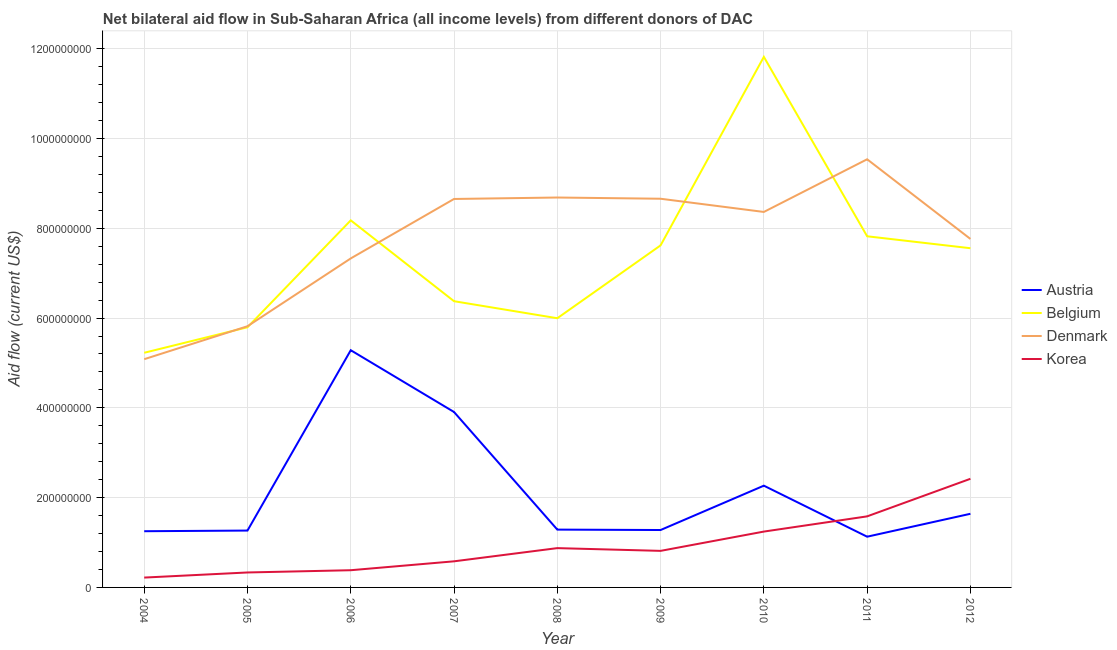Is the number of lines equal to the number of legend labels?
Make the answer very short. Yes. What is the amount of aid given by belgium in 2009?
Your answer should be very brief. 7.62e+08. Across all years, what is the maximum amount of aid given by austria?
Provide a short and direct response. 5.28e+08. Across all years, what is the minimum amount of aid given by belgium?
Provide a short and direct response. 5.23e+08. In which year was the amount of aid given by austria maximum?
Ensure brevity in your answer.  2006. In which year was the amount of aid given by austria minimum?
Your answer should be very brief. 2011. What is the total amount of aid given by austria in the graph?
Give a very brief answer. 1.93e+09. What is the difference between the amount of aid given by korea in 2004 and that in 2009?
Your answer should be very brief. -5.95e+07. What is the difference between the amount of aid given by korea in 2011 and the amount of aid given by austria in 2009?
Your answer should be very brief. 3.04e+07. What is the average amount of aid given by belgium per year?
Offer a very short reply. 7.38e+08. In the year 2004, what is the difference between the amount of aid given by denmark and amount of aid given by belgium?
Offer a terse response. -1.43e+07. In how many years, is the amount of aid given by korea greater than 160000000 US$?
Provide a short and direct response. 1. What is the ratio of the amount of aid given by austria in 2004 to that in 2011?
Keep it short and to the point. 1.11. Is the amount of aid given by austria in 2006 less than that in 2011?
Make the answer very short. No. Is the difference between the amount of aid given by belgium in 2008 and 2011 greater than the difference between the amount of aid given by korea in 2008 and 2011?
Your answer should be compact. No. What is the difference between the highest and the second highest amount of aid given by austria?
Provide a succinct answer. 1.38e+08. What is the difference between the highest and the lowest amount of aid given by belgium?
Your response must be concise. 6.59e+08. Is it the case that in every year, the sum of the amount of aid given by denmark and amount of aid given by belgium is greater than the sum of amount of aid given by austria and amount of aid given by korea?
Keep it short and to the point. Yes. What is the difference between two consecutive major ticks on the Y-axis?
Ensure brevity in your answer.  2.00e+08. How are the legend labels stacked?
Provide a succinct answer. Vertical. What is the title of the graph?
Give a very brief answer. Net bilateral aid flow in Sub-Saharan Africa (all income levels) from different donors of DAC. What is the label or title of the X-axis?
Your answer should be compact. Year. What is the Aid flow (current US$) in Austria in 2004?
Your answer should be very brief. 1.25e+08. What is the Aid flow (current US$) of Belgium in 2004?
Keep it short and to the point. 5.23e+08. What is the Aid flow (current US$) in Denmark in 2004?
Make the answer very short. 5.08e+08. What is the Aid flow (current US$) in Korea in 2004?
Ensure brevity in your answer.  2.19e+07. What is the Aid flow (current US$) in Austria in 2005?
Provide a short and direct response. 1.27e+08. What is the Aid flow (current US$) in Belgium in 2005?
Offer a very short reply. 5.79e+08. What is the Aid flow (current US$) of Denmark in 2005?
Provide a short and direct response. 5.82e+08. What is the Aid flow (current US$) in Korea in 2005?
Provide a succinct answer. 3.33e+07. What is the Aid flow (current US$) of Austria in 2006?
Make the answer very short. 5.28e+08. What is the Aid flow (current US$) of Belgium in 2006?
Offer a very short reply. 8.18e+08. What is the Aid flow (current US$) of Denmark in 2006?
Give a very brief answer. 7.33e+08. What is the Aid flow (current US$) in Korea in 2006?
Give a very brief answer. 3.83e+07. What is the Aid flow (current US$) in Austria in 2007?
Your response must be concise. 3.91e+08. What is the Aid flow (current US$) in Belgium in 2007?
Provide a short and direct response. 6.38e+08. What is the Aid flow (current US$) in Denmark in 2007?
Ensure brevity in your answer.  8.65e+08. What is the Aid flow (current US$) of Korea in 2007?
Make the answer very short. 5.82e+07. What is the Aid flow (current US$) in Austria in 2008?
Your answer should be compact. 1.29e+08. What is the Aid flow (current US$) in Belgium in 2008?
Your answer should be very brief. 6.00e+08. What is the Aid flow (current US$) in Denmark in 2008?
Offer a very short reply. 8.68e+08. What is the Aid flow (current US$) in Korea in 2008?
Give a very brief answer. 8.76e+07. What is the Aid flow (current US$) in Austria in 2009?
Your response must be concise. 1.28e+08. What is the Aid flow (current US$) of Belgium in 2009?
Give a very brief answer. 7.62e+08. What is the Aid flow (current US$) of Denmark in 2009?
Make the answer very short. 8.66e+08. What is the Aid flow (current US$) of Korea in 2009?
Give a very brief answer. 8.14e+07. What is the Aid flow (current US$) of Austria in 2010?
Ensure brevity in your answer.  2.27e+08. What is the Aid flow (current US$) in Belgium in 2010?
Your answer should be very brief. 1.18e+09. What is the Aid flow (current US$) in Denmark in 2010?
Give a very brief answer. 8.36e+08. What is the Aid flow (current US$) in Korea in 2010?
Your answer should be very brief. 1.24e+08. What is the Aid flow (current US$) in Austria in 2011?
Give a very brief answer. 1.13e+08. What is the Aid flow (current US$) of Belgium in 2011?
Your response must be concise. 7.82e+08. What is the Aid flow (current US$) in Denmark in 2011?
Make the answer very short. 9.54e+08. What is the Aid flow (current US$) of Korea in 2011?
Offer a terse response. 1.58e+08. What is the Aid flow (current US$) in Austria in 2012?
Your answer should be very brief. 1.64e+08. What is the Aid flow (current US$) of Belgium in 2012?
Your response must be concise. 7.56e+08. What is the Aid flow (current US$) in Denmark in 2012?
Provide a succinct answer. 7.76e+08. What is the Aid flow (current US$) of Korea in 2012?
Offer a very short reply. 2.42e+08. Across all years, what is the maximum Aid flow (current US$) of Austria?
Give a very brief answer. 5.28e+08. Across all years, what is the maximum Aid flow (current US$) of Belgium?
Make the answer very short. 1.18e+09. Across all years, what is the maximum Aid flow (current US$) of Denmark?
Keep it short and to the point. 9.54e+08. Across all years, what is the maximum Aid flow (current US$) of Korea?
Your response must be concise. 2.42e+08. Across all years, what is the minimum Aid flow (current US$) in Austria?
Your answer should be very brief. 1.13e+08. Across all years, what is the minimum Aid flow (current US$) in Belgium?
Provide a succinct answer. 5.23e+08. Across all years, what is the minimum Aid flow (current US$) of Denmark?
Offer a terse response. 5.08e+08. Across all years, what is the minimum Aid flow (current US$) of Korea?
Provide a succinct answer. 2.19e+07. What is the total Aid flow (current US$) in Austria in the graph?
Make the answer very short. 1.93e+09. What is the total Aid flow (current US$) of Belgium in the graph?
Give a very brief answer. 6.64e+09. What is the total Aid flow (current US$) in Denmark in the graph?
Keep it short and to the point. 6.99e+09. What is the total Aid flow (current US$) in Korea in the graph?
Give a very brief answer. 8.45e+08. What is the difference between the Aid flow (current US$) of Austria in 2004 and that in 2005?
Offer a terse response. -1.43e+06. What is the difference between the Aid flow (current US$) of Belgium in 2004 and that in 2005?
Offer a very short reply. -5.68e+07. What is the difference between the Aid flow (current US$) in Denmark in 2004 and that in 2005?
Keep it short and to the point. -7.34e+07. What is the difference between the Aid flow (current US$) of Korea in 2004 and that in 2005?
Give a very brief answer. -1.14e+07. What is the difference between the Aid flow (current US$) of Austria in 2004 and that in 2006?
Your response must be concise. -4.03e+08. What is the difference between the Aid flow (current US$) in Belgium in 2004 and that in 2006?
Provide a short and direct response. -2.95e+08. What is the difference between the Aid flow (current US$) in Denmark in 2004 and that in 2006?
Your answer should be compact. -2.24e+08. What is the difference between the Aid flow (current US$) of Korea in 2004 and that in 2006?
Offer a terse response. -1.64e+07. What is the difference between the Aid flow (current US$) of Austria in 2004 and that in 2007?
Your response must be concise. -2.66e+08. What is the difference between the Aid flow (current US$) in Belgium in 2004 and that in 2007?
Make the answer very short. -1.15e+08. What is the difference between the Aid flow (current US$) of Denmark in 2004 and that in 2007?
Give a very brief answer. -3.57e+08. What is the difference between the Aid flow (current US$) in Korea in 2004 and that in 2007?
Ensure brevity in your answer.  -3.62e+07. What is the difference between the Aid flow (current US$) of Austria in 2004 and that in 2008?
Offer a very short reply. -3.58e+06. What is the difference between the Aid flow (current US$) in Belgium in 2004 and that in 2008?
Give a very brief answer. -7.69e+07. What is the difference between the Aid flow (current US$) in Denmark in 2004 and that in 2008?
Offer a very short reply. -3.60e+08. What is the difference between the Aid flow (current US$) in Korea in 2004 and that in 2008?
Give a very brief answer. -6.56e+07. What is the difference between the Aid flow (current US$) in Austria in 2004 and that in 2009?
Make the answer very short. -2.67e+06. What is the difference between the Aid flow (current US$) in Belgium in 2004 and that in 2009?
Give a very brief answer. -2.39e+08. What is the difference between the Aid flow (current US$) of Denmark in 2004 and that in 2009?
Keep it short and to the point. -3.57e+08. What is the difference between the Aid flow (current US$) of Korea in 2004 and that in 2009?
Your answer should be very brief. -5.95e+07. What is the difference between the Aid flow (current US$) in Austria in 2004 and that in 2010?
Offer a very short reply. -1.01e+08. What is the difference between the Aid flow (current US$) in Belgium in 2004 and that in 2010?
Your answer should be very brief. -6.59e+08. What is the difference between the Aid flow (current US$) in Denmark in 2004 and that in 2010?
Your answer should be very brief. -3.28e+08. What is the difference between the Aid flow (current US$) in Korea in 2004 and that in 2010?
Give a very brief answer. -1.02e+08. What is the difference between the Aid flow (current US$) in Austria in 2004 and that in 2011?
Give a very brief answer. 1.22e+07. What is the difference between the Aid flow (current US$) of Belgium in 2004 and that in 2011?
Keep it short and to the point. -2.59e+08. What is the difference between the Aid flow (current US$) in Denmark in 2004 and that in 2011?
Offer a terse response. -4.45e+08. What is the difference between the Aid flow (current US$) in Korea in 2004 and that in 2011?
Your response must be concise. -1.36e+08. What is the difference between the Aid flow (current US$) in Austria in 2004 and that in 2012?
Your response must be concise. -3.88e+07. What is the difference between the Aid flow (current US$) of Belgium in 2004 and that in 2012?
Provide a succinct answer. -2.33e+08. What is the difference between the Aid flow (current US$) of Denmark in 2004 and that in 2012?
Your response must be concise. -2.68e+08. What is the difference between the Aid flow (current US$) of Korea in 2004 and that in 2012?
Your answer should be compact. -2.20e+08. What is the difference between the Aid flow (current US$) of Austria in 2005 and that in 2006?
Keep it short and to the point. -4.02e+08. What is the difference between the Aid flow (current US$) in Belgium in 2005 and that in 2006?
Your answer should be compact. -2.38e+08. What is the difference between the Aid flow (current US$) of Denmark in 2005 and that in 2006?
Provide a short and direct response. -1.51e+08. What is the difference between the Aid flow (current US$) of Korea in 2005 and that in 2006?
Your response must be concise. -5.01e+06. What is the difference between the Aid flow (current US$) of Austria in 2005 and that in 2007?
Provide a short and direct response. -2.64e+08. What is the difference between the Aid flow (current US$) in Belgium in 2005 and that in 2007?
Make the answer very short. -5.80e+07. What is the difference between the Aid flow (current US$) in Denmark in 2005 and that in 2007?
Offer a terse response. -2.83e+08. What is the difference between the Aid flow (current US$) in Korea in 2005 and that in 2007?
Your answer should be compact. -2.48e+07. What is the difference between the Aid flow (current US$) in Austria in 2005 and that in 2008?
Offer a terse response. -2.15e+06. What is the difference between the Aid flow (current US$) in Belgium in 2005 and that in 2008?
Ensure brevity in your answer.  -2.01e+07. What is the difference between the Aid flow (current US$) in Denmark in 2005 and that in 2008?
Make the answer very short. -2.87e+08. What is the difference between the Aid flow (current US$) in Korea in 2005 and that in 2008?
Your answer should be compact. -5.42e+07. What is the difference between the Aid flow (current US$) in Austria in 2005 and that in 2009?
Give a very brief answer. -1.24e+06. What is the difference between the Aid flow (current US$) in Belgium in 2005 and that in 2009?
Ensure brevity in your answer.  -1.82e+08. What is the difference between the Aid flow (current US$) in Denmark in 2005 and that in 2009?
Provide a short and direct response. -2.84e+08. What is the difference between the Aid flow (current US$) of Korea in 2005 and that in 2009?
Your answer should be very brief. -4.81e+07. What is the difference between the Aid flow (current US$) in Austria in 2005 and that in 2010?
Your answer should be very brief. -1.00e+08. What is the difference between the Aid flow (current US$) in Belgium in 2005 and that in 2010?
Keep it short and to the point. -6.02e+08. What is the difference between the Aid flow (current US$) in Denmark in 2005 and that in 2010?
Your answer should be compact. -2.55e+08. What is the difference between the Aid flow (current US$) of Korea in 2005 and that in 2010?
Offer a very short reply. -9.11e+07. What is the difference between the Aid flow (current US$) in Austria in 2005 and that in 2011?
Give a very brief answer. 1.36e+07. What is the difference between the Aid flow (current US$) in Belgium in 2005 and that in 2011?
Make the answer very short. -2.03e+08. What is the difference between the Aid flow (current US$) of Denmark in 2005 and that in 2011?
Your response must be concise. -3.72e+08. What is the difference between the Aid flow (current US$) of Korea in 2005 and that in 2011?
Provide a succinct answer. -1.25e+08. What is the difference between the Aid flow (current US$) in Austria in 2005 and that in 2012?
Provide a short and direct response. -3.74e+07. What is the difference between the Aid flow (current US$) of Belgium in 2005 and that in 2012?
Provide a short and direct response. -1.76e+08. What is the difference between the Aid flow (current US$) of Denmark in 2005 and that in 2012?
Ensure brevity in your answer.  -1.94e+08. What is the difference between the Aid flow (current US$) in Korea in 2005 and that in 2012?
Offer a terse response. -2.09e+08. What is the difference between the Aid flow (current US$) in Austria in 2006 and that in 2007?
Offer a very short reply. 1.38e+08. What is the difference between the Aid flow (current US$) in Belgium in 2006 and that in 2007?
Your answer should be very brief. 1.80e+08. What is the difference between the Aid flow (current US$) in Denmark in 2006 and that in 2007?
Ensure brevity in your answer.  -1.32e+08. What is the difference between the Aid flow (current US$) of Korea in 2006 and that in 2007?
Provide a short and direct response. -1.98e+07. What is the difference between the Aid flow (current US$) of Austria in 2006 and that in 2008?
Offer a terse response. 4.00e+08. What is the difference between the Aid flow (current US$) in Belgium in 2006 and that in 2008?
Give a very brief answer. 2.18e+08. What is the difference between the Aid flow (current US$) of Denmark in 2006 and that in 2008?
Ensure brevity in your answer.  -1.36e+08. What is the difference between the Aid flow (current US$) in Korea in 2006 and that in 2008?
Your answer should be compact. -4.92e+07. What is the difference between the Aid flow (current US$) in Austria in 2006 and that in 2009?
Give a very brief answer. 4.00e+08. What is the difference between the Aid flow (current US$) in Belgium in 2006 and that in 2009?
Your answer should be compact. 5.57e+07. What is the difference between the Aid flow (current US$) in Denmark in 2006 and that in 2009?
Provide a short and direct response. -1.33e+08. What is the difference between the Aid flow (current US$) in Korea in 2006 and that in 2009?
Give a very brief answer. -4.31e+07. What is the difference between the Aid flow (current US$) in Austria in 2006 and that in 2010?
Give a very brief answer. 3.02e+08. What is the difference between the Aid flow (current US$) of Belgium in 2006 and that in 2010?
Make the answer very short. -3.64e+08. What is the difference between the Aid flow (current US$) in Denmark in 2006 and that in 2010?
Offer a very short reply. -1.04e+08. What is the difference between the Aid flow (current US$) of Korea in 2006 and that in 2010?
Provide a succinct answer. -8.61e+07. What is the difference between the Aid flow (current US$) of Austria in 2006 and that in 2011?
Your answer should be very brief. 4.15e+08. What is the difference between the Aid flow (current US$) in Belgium in 2006 and that in 2011?
Ensure brevity in your answer.  3.55e+07. What is the difference between the Aid flow (current US$) of Denmark in 2006 and that in 2011?
Your answer should be compact. -2.21e+08. What is the difference between the Aid flow (current US$) in Korea in 2006 and that in 2011?
Make the answer very short. -1.20e+08. What is the difference between the Aid flow (current US$) of Austria in 2006 and that in 2012?
Your answer should be compact. 3.64e+08. What is the difference between the Aid flow (current US$) of Belgium in 2006 and that in 2012?
Offer a very short reply. 6.21e+07. What is the difference between the Aid flow (current US$) in Denmark in 2006 and that in 2012?
Make the answer very short. -4.34e+07. What is the difference between the Aid flow (current US$) in Korea in 2006 and that in 2012?
Your response must be concise. -2.04e+08. What is the difference between the Aid flow (current US$) in Austria in 2007 and that in 2008?
Your answer should be compact. 2.62e+08. What is the difference between the Aid flow (current US$) in Belgium in 2007 and that in 2008?
Give a very brief answer. 3.79e+07. What is the difference between the Aid flow (current US$) in Denmark in 2007 and that in 2008?
Provide a succinct answer. -3.24e+06. What is the difference between the Aid flow (current US$) of Korea in 2007 and that in 2008?
Keep it short and to the point. -2.94e+07. What is the difference between the Aid flow (current US$) of Austria in 2007 and that in 2009?
Your response must be concise. 2.63e+08. What is the difference between the Aid flow (current US$) in Belgium in 2007 and that in 2009?
Ensure brevity in your answer.  -1.24e+08. What is the difference between the Aid flow (current US$) in Denmark in 2007 and that in 2009?
Offer a terse response. -5.00e+05. What is the difference between the Aid flow (current US$) in Korea in 2007 and that in 2009?
Offer a terse response. -2.33e+07. What is the difference between the Aid flow (current US$) of Austria in 2007 and that in 2010?
Provide a short and direct response. 1.64e+08. What is the difference between the Aid flow (current US$) of Belgium in 2007 and that in 2010?
Provide a short and direct response. -5.44e+08. What is the difference between the Aid flow (current US$) in Denmark in 2007 and that in 2010?
Make the answer very short. 2.89e+07. What is the difference between the Aid flow (current US$) of Korea in 2007 and that in 2010?
Provide a short and direct response. -6.62e+07. What is the difference between the Aid flow (current US$) in Austria in 2007 and that in 2011?
Provide a succinct answer. 2.78e+08. What is the difference between the Aid flow (current US$) of Belgium in 2007 and that in 2011?
Offer a very short reply. -1.45e+08. What is the difference between the Aid flow (current US$) in Denmark in 2007 and that in 2011?
Offer a very short reply. -8.84e+07. What is the difference between the Aid flow (current US$) in Korea in 2007 and that in 2011?
Offer a very short reply. -1.00e+08. What is the difference between the Aid flow (current US$) in Austria in 2007 and that in 2012?
Your answer should be compact. 2.27e+08. What is the difference between the Aid flow (current US$) of Belgium in 2007 and that in 2012?
Make the answer very short. -1.18e+08. What is the difference between the Aid flow (current US$) of Denmark in 2007 and that in 2012?
Provide a succinct answer. 8.90e+07. What is the difference between the Aid flow (current US$) in Korea in 2007 and that in 2012?
Make the answer very short. -1.84e+08. What is the difference between the Aid flow (current US$) in Austria in 2008 and that in 2009?
Your response must be concise. 9.10e+05. What is the difference between the Aid flow (current US$) in Belgium in 2008 and that in 2009?
Offer a very short reply. -1.62e+08. What is the difference between the Aid flow (current US$) of Denmark in 2008 and that in 2009?
Keep it short and to the point. 2.74e+06. What is the difference between the Aid flow (current US$) of Korea in 2008 and that in 2009?
Make the answer very short. 6.12e+06. What is the difference between the Aid flow (current US$) of Austria in 2008 and that in 2010?
Your response must be concise. -9.78e+07. What is the difference between the Aid flow (current US$) of Belgium in 2008 and that in 2010?
Ensure brevity in your answer.  -5.82e+08. What is the difference between the Aid flow (current US$) in Denmark in 2008 and that in 2010?
Ensure brevity in your answer.  3.21e+07. What is the difference between the Aid flow (current US$) in Korea in 2008 and that in 2010?
Your response must be concise. -3.68e+07. What is the difference between the Aid flow (current US$) in Austria in 2008 and that in 2011?
Make the answer very short. 1.58e+07. What is the difference between the Aid flow (current US$) in Belgium in 2008 and that in 2011?
Make the answer very short. -1.83e+08. What is the difference between the Aid flow (current US$) in Denmark in 2008 and that in 2011?
Make the answer very short. -8.52e+07. What is the difference between the Aid flow (current US$) of Korea in 2008 and that in 2011?
Ensure brevity in your answer.  -7.07e+07. What is the difference between the Aid flow (current US$) of Austria in 2008 and that in 2012?
Keep it short and to the point. -3.52e+07. What is the difference between the Aid flow (current US$) of Belgium in 2008 and that in 2012?
Make the answer very short. -1.56e+08. What is the difference between the Aid flow (current US$) in Denmark in 2008 and that in 2012?
Make the answer very short. 9.23e+07. What is the difference between the Aid flow (current US$) of Korea in 2008 and that in 2012?
Ensure brevity in your answer.  -1.54e+08. What is the difference between the Aid flow (current US$) in Austria in 2009 and that in 2010?
Offer a very short reply. -9.88e+07. What is the difference between the Aid flow (current US$) of Belgium in 2009 and that in 2010?
Offer a terse response. -4.20e+08. What is the difference between the Aid flow (current US$) in Denmark in 2009 and that in 2010?
Give a very brief answer. 2.94e+07. What is the difference between the Aid flow (current US$) in Korea in 2009 and that in 2010?
Offer a very short reply. -4.30e+07. What is the difference between the Aid flow (current US$) of Austria in 2009 and that in 2011?
Provide a short and direct response. 1.49e+07. What is the difference between the Aid flow (current US$) of Belgium in 2009 and that in 2011?
Offer a very short reply. -2.03e+07. What is the difference between the Aid flow (current US$) of Denmark in 2009 and that in 2011?
Your answer should be very brief. -8.79e+07. What is the difference between the Aid flow (current US$) of Korea in 2009 and that in 2011?
Your answer should be very brief. -7.68e+07. What is the difference between the Aid flow (current US$) of Austria in 2009 and that in 2012?
Provide a succinct answer. -3.62e+07. What is the difference between the Aid flow (current US$) of Belgium in 2009 and that in 2012?
Make the answer very short. 6.34e+06. What is the difference between the Aid flow (current US$) in Denmark in 2009 and that in 2012?
Your answer should be very brief. 8.95e+07. What is the difference between the Aid flow (current US$) of Korea in 2009 and that in 2012?
Ensure brevity in your answer.  -1.61e+08. What is the difference between the Aid flow (current US$) of Austria in 2010 and that in 2011?
Your response must be concise. 1.14e+08. What is the difference between the Aid flow (current US$) in Belgium in 2010 and that in 2011?
Your answer should be very brief. 4.00e+08. What is the difference between the Aid flow (current US$) of Denmark in 2010 and that in 2011?
Offer a very short reply. -1.17e+08. What is the difference between the Aid flow (current US$) of Korea in 2010 and that in 2011?
Make the answer very short. -3.39e+07. What is the difference between the Aid flow (current US$) in Austria in 2010 and that in 2012?
Your answer should be very brief. 6.26e+07. What is the difference between the Aid flow (current US$) of Belgium in 2010 and that in 2012?
Provide a succinct answer. 4.26e+08. What is the difference between the Aid flow (current US$) of Denmark in 2010 and that in 2012?
Your answer should be compact. 6.01e+07. What is the difference between the Aid flow (current US$) in Korea in 2010 and that in 2012?
Your response must be concise. -1.18e+08. What is the difference between the Aid flow (current US$) of Austria in 2011 and that in 2012?
Offer a very short reply. -5.10e+07. What is the difference between the Aid flow (current US$) in Belgium in 2011 and that in 2012?
Keep it short and to the point. 2.66e+07. What is the difference between the Aid flow (current US$) in Denmark in 2011 and that in 2012?
Ensure brevity in your answer.  1.77e+08. What is the difference between the Aid flow (current US$) in Korea in 2011 and that in 2012?
Offer a very short reply. -8.37e+07. What is the difference between the Aid flow (current US$) of Austria in 2004 and the Aid flow (current US$) of Belgium in 2005?
Offer a terse response. -4.54e+08. What is the difference between the Aid flow (current US$) of Austria in 2004 and the Aid flow (current US$) of Denmark in 2005?
Your response must be concise. -4.57e+08. What is the difference between the Aid flow (current US$) in Austria in 2004 and the Aid flow (current US$) in Korea in 2005?
Offer a terse response. 9.19e+07. What is the difference between the Aid flow (current US$) in Belgium in 2004 and the Aid flow (current US$) in Denmark in 2005?
Offer a terse response. -5.91e+07. What is the difference between the Aid flow (current US$) in Belgium in 2004 and the Aid flow (current US$) in Korea in 2005?
Keep it short and to the point. 4.89e+08. What is the difference between the Aid flow (current US$) of Denmark in 2004 and the Aid flow (current US$) of Korea in 2005?
Your response must be concise. 4.75e+08. What is the difference between the Aid flow (current US$) of Austria in 2004 and the Aid flow (current US$) of Belgium in 2006?
Give a very brief answer. -6.92e+08. What is the difference between the Aid flow (current US$) of Austria in 2004 and the Aid flow (current US$) of Denmark in 2006?
Your answer should be compact. -6.08e+08. What is the difference between the Aid flow (current US$) in Austria in 2004 and the Aid flow (current US$) in Korea in 2006?
Offer a terse response. 8.69e+07. What is the difference between the Aid flow (current US$) of Belgium in 2004 and the Aid flow (current US$) of Denmark in 2006?
Your answer should be very brief. -2.10e+08. What is the difference between the Aid flow (current US$) of Belgium in 2004 and the Aid flow (current US$) of Korea in 2006?
Provide a succinct answer. 4.84e+08. What is the difference between the Aid flow (current US$) in Denmark in 2004 and the Aid flow (current US$) in Korea in 2006?
Your answer should be compact. 4.70e+08. What is the difference between the Aid flow (current US$) in Austria in 2004 and the Aid flow (current US$) in Belgium in 2007?
Offer a very short reply. -5.12e+08. What is the difference between the Aid flow (current US$) in Austria in 2004 and the Aid flow (current US$) in Denmark in 2007?
Your answer should be very brief. -7.40e+08. What is the difference between the Aid flow (current US$) in Austria in 2004 and the Aid flow (current US$) in Korea in 2007?
Your response must be concise. 6.71e+07. What is the difference between the Aid flow (current US$) in Belgium in 2004 and the Aid flow (current US$) in Denmark in 2007?
Your answer should be very brief. -3.43e+08. What is the difference between the Aid flow (current US$) in Belgium in 2004 and the Aid flow (current US$) in Korea in 2007?
Ensure brevity in your answer.  4.65e+08. What is the difference between the Aid flow (current US$) in Denmark in 2004 and the Aid flow (current US$) in Korea in 2007?
Offer a terse response. 4.50e+08. What is the difference between the Aid flow (current US$) of Austria in 2004 and the Aid flow (current US$) of Belgium in 2008?
Keep it short and to the point. -4.74e+08. What is the difference between the Aid flow (current US$) in Austria in 2004 and the Aid flow (current US$) in Denmark in 2008?
Give a very brief answer. -7.43e+08. What is the difference between the Aid flow (current US$) of Austria in 2004 and the Aid flow (current US$) of Korea in 2008?
Offer a very short reply. 3.77e+07. What is the difference between the Aid flow (current US$) of Belgium in 2004 and the Aid flow (current US$) of Denmark in 2008?
Give a very brief answer. -3.46e+08. What is the difference between the Aid flow (current US$) in Belgium in 2004 and the Aid flow (current US$) in Korea in 2008?
Provide a succinct answer. 4.35e+08. What is the difference between the Aid flow (current US$) in Denmark in 2004 and the Aid flow (current US$) in Korea in 2008?
Provide a succinct answer. 4.21e+08. What is the difference between the Aid flow (current US$) of Austria in 2004 and the Aid flow (current US$) of Belgium in 2009?
Provide a short and direct response. -6.37e+08. What is the difference between the Aid flow (current US$) in Austria in 2004 and the Aid flow (current US$) in Denmark in 2009?
Your response must be concise. -7.41e+08. What is the difference between the Aid flow (current US$) in Austria in 2004 and the Aid flow (current US$) in Korea in 2009?
Your answer should be compact. 4.38e+07. What is the difference between the Aid flow (current US$) of Belgium in 2004 and the Aid flow (current US$) of Denmark in 2009?
Make the answer very short. -3.43e+08. What is the difference between the Aid flow (current US$) in Belgium in 2004 and the Aid flow (current US$) in Korea in 2009?
Provide a succinct answer. 4.41e+08. What is the difference between the Aid flow (current US$) in Denmark in 2004 and the Aid flow (current US$) in Korea in 2009?
Your response must be concise. 4.27e+08. What is the difference between the Aid flow (current US$) of Austria in 2004 and the Aid flow (current US$) of Belgium in 2010?
Keep it short and to the point. -1.06e+09. What is the difference between the Aid flow (current US$) of Austria in 2004 and the Aid flow (current US$) of Denmark in 2010?
Keep it short and to the point. -7.11e+08. What is the difference between the Aid flow (current US$) in Austria in 2004 and the Aid flow (current US$) in Korea in 2010?
Offer a terse response. 8.20e+05. What is the difference between the Aid flow (current US$) of Belgium in 2004 and the Aid flow (current US$) of Denmark in 2010?
Give a very brief answer. -3.14e+08. What is the difference between the Aid flow (current US$) of Belgium in 2004 and the Aid flow (current US$) of Korea in 2010?
Offer a very short reply. 3.98e+08. What is the difference between the Aid flow (current US$) in Denmark in 2004 and the Aid flow (current US$) in Korea in 2010?
Offer a very short reply. 3.84e+08. What is the difference between the Aid flow (current US$) in Austria in 2004 and the Aid flow (current US$) in Belgium in 2011?
Provide a succinct answer. -6.57e+08. What is the difference between the Aid flow (current US$) in Austria in 2004 and the Aid flow (current US$) in Denmark in 2011?
Offer a very short reply. -8.28e+08. What is the difference between the Aid flow (current US$) in Austria in 2004 and the Aid flow (current US$) in Korea in 2011?
Provide a short and direct response. -3.31e+07. What is the difference between the Aid flow (current US$) in Belgium in 2004 and the Aid flow (current US$) in Denmark in 2011?
Provide a succinct answer. -4.31e+08. What is the difference between the Aid flow (current US$) in Belgium in 2004 and the Aid flow (current US$) in Korea in 2011?
Give a very brief answer. 3.64e+08. What is the difference between the Aid flow (current US$) of Denmark in 2004 and the Aid flow (current US$) of Korea in 2011?
Offer a very short reply. 3.50e+08. What is the difference between the Aid flow (current US$) in Austria in 2004 and the Aid flow (current US$) in Belgium in 2012?
Your response must be concise. -6.30e+08. What is the difference between the Aid flow (current US$) of Austria in 2004 and the Aid flow (current US$) of Denmark in 2012?
Make the answer very short. -6.51e+08. What is the difference between the Aid flow (current US$) in Austria in 2004 and the Aid flow (current US$) in Korea in 2012?
Ensure brevity in your answer.  -1.17e+08. What is the difference between the Aid flow (current US$) in Belgium in 2004 and the Aid flow (current US$) in Denmark in 2012?
Keep it short and to the point. -2.54e+08. What is the difference between the Aid flow (current US$) of Belgium in 2004 and the Aid flow (current US$) of Korea in 2012?
Offer a very short reply. 2.81e+08. What is the difference between the Aid flow (current US$) of Denmark in 2004 and the Aid flow (current US$) of Korea in 2012?
Your answer should be compact. 2.66e+08. What is the difference between the Aid flow (current US$) of Austria in 2005 and the Aid flow (current US$) of Belgium in 2006?
Ensure brevity in your answer.  -6.91e+08. What is the difference between the Aid flow (current US$) of Austria in 2005 and the Aid flow (current US$) of Denmark in 2006?
Offer a very short reply. -6.06e+08. What is the difference between the Aid flow (current US$) in Austria in 2005 and the Aid flow (current US$) in Korea in 2006?
Your answer should be very brief. 8.83e+07. What is the difference between the Aid flow (current US$) of Belgium in 2005 and the Aid flow (current US$) of Denmark in 2006?
Keep it short and to the point. -1.53e+08. What is the difference between the Aid flow (current US$) of Belgium in 2005 and the Aid flow (current US$) of Korea in 2006?
Your response must be concise. 5.41e+08. What is the difference between the Aid flow (current US$) in Denmark in 2005 and the Aid flow (current US$) in Korea in 2006?
Give a very brief answer. 5.43e+08. What is the difference between the Aid flow (current US$) of Austria in 2005 and the Aid flow (current US$) of Belgium in 2007?
Your answer should be very brief. -5.11e+08. What is the difference between the Aid flow (current US$) of Austria in 2005 and the Aid flow (current US$) of Denmark in 2007?
Provide a short and direct response. -7.39e+08. What is the difference between the Aid flow (current US$) of Austria in 2005 and the Aid flow (current US$) of Korea in 2007?
Provide a succinct answer. 6.85e+07. What is the difference between the Aid flow (current US$) in Belgium in 2005 and the Aid flow (current US$) in Denmark in 2007?
Make the answer very short. -2.86e+08. What is the difference between the Aid flow (current US$) in Belgium in 2005 and the Aid flow (current US$) in Korea in 2007?
Keep it short and to the point. 5.21e+08. What is the difference between the Aid flow (current US$) of Denmark in 2005 and the Aid flow (current US$) of Korea in 2007?
Give a very brief answer. 5.24e+08. What is the difference between the Aid flow (current US$) of Austria in 2005 and the Aid flow (current US$) of Belgium in 2008?
Your response must be concise. -4.73e+08. What is the difference between the Aid flow (current US$) of Austria in 2005 and the Aid flow (current US$) of Denmark in 2008?
Your answer should be compact. -7.42e+08. What is the difference between the Aid flow (current US$) in Austria in 2005 and the Aid flow (current US$) in Korea in 2008?
Your answer should be very brief. 3.91e+07. What is the difference between the Aid flow (current US$) in Belgium in 2005 and the Aid flow (current US$) in Denmark in 2008?
Give a very brief answer. -2.89e+08. What is the difference between the Aid flow (current US$) in Belgium in 2005 and the Aid flow (current US$) in Korea in 2008?
Keep it short and to the point. 4.92e+08. What is the difference between the Aid flow (current US$) in Denmark in 2005 and the Aid flow (current US$) in Korea in 2008?
Offer a terse response. 4.94e+08. What is the difference between the Aid flow (current US$) of Austria in 2005 and the Aid flow (current US$) of Belgium in 2009?
Your answer should be very brief. -6.35e+08. What is the difference between the Aid flow (current US$) in Austria in 2005 and the Aid flow (current US$) in Denmark in 2009?
Your answer should be compact. -7.39e+08. What is the difference between the Aid flow (current US$) of Austria in 2005 and the Aid flow (current US$) of Korea in 2009?
Make the answer very short. 4.52e+07. What is the difference between the Aid flow (current US$) of Belgium in 2005 and the Aid flow (current US$) of Denmark in 2009?
Offer a very short reply. -2.86e+08. What is the difference between the Aid flow (current US$) of Belgium in 2005 and the Aid flow (current US$) of Korea in 2009?
Keep it short and to the point. 4.98e+08. What is the difference between the Aid flow (current US$) in Denmark in 2005 and the Aid flow (current US$) in Korea in 2009?
Provide a short and direct response. 5.00e+08. What is the difference between the Aid flow (current US$) of Austria in 2005 and the Aid flow (current US$) of Belgium in 2010?
Provide a short and direct response. -1.06e+09. What is the difference between the Aid flow (current US$) of Austria in 2005 and the Aid flow (current US$) of Denmark in 2010?
Provide a short and direct response. -7.10e+08. What is the difference between the Aid flow (current US$) in Austria in 2005 and the Aid flow (current US$) in Korea in 2010?
Make the answer very short. 2.25e+06. What is the difference between the Aid flow (current US$) in Belgium in 2005 and the Aid flow (current US$) in Denmark in 2010?
Your answer should be very brief. -2.57e+08. What is the difference between the Aid flow (current US$) of Belgium in 2005 and the Aid flow (current US$) of Korea in 2010?
Your answer should be compact. 4.55e+08. What is the difference between the Aid flow (current US$) of Denmark in 2005 and the Aid flow (current US$) of Korea in 2010?
Provide a succinct answer. 4.57e+08. What is the difference between the Aid flow (current US$) of Austria in 2005 and the Aid flow (current US$) of Belgium in 2011?
Make the answer very short. -6.55e+08. What is the difference between the Aid flow (current US$) of Austria in 2005 and the Aid flow (current US$) of Denmark in 2011?
Make the answer very short. -8.27e+08. What is the difference between the Aid flow (current US$) in Austria in 2005 and the Aid flow (current US$) in Korea in 2011?
Make the answer very short. -3.16e+07. What is the difference between the Aid flow (current US$) in Belgium in 2005 and the Aid flow (current US$) in Denmark in 2011?
Offer a very short reply. -3.74e+08. What is the difference between the Aid flow (current US$) of Belgium in 2005 and the Aid flow (current US$) of Korea in 2011?
Offer a terse response. 4.21e+08. What is the difference between the Aid flow (current US$) in Denmark in 2005 and the Aid flow (current US$) in Korea in 2011?
Provide a short and direct response. 4.23e+08. What is the difference between the Aid flow (current US$) of Austria in 2005 and the Aid flow (current US$) of Belgium in 2012?
Give a very brief answer. -6.29e+08. What is the difference between the Aid flow (current US$) in Austria in 2005 and the Aid flow (current US$) in Denmark in 2012?
Your response must be concise. -6.50e+08. What is the difference between the Aid flow (current US$) in Austria in 2005 and the Aid flow (current US$) in Korea in 2012?
Give a very brief answer. -1.15e+08. What is the difference between the Aid flow (current US$) of Belgium in 2005 and the Aid flow (current US$) of Denmark in 2012?
Your answer should be very brief. -1.97e+08. What is the difference between the Aid flow (current US$) in Belgium in 2005 and the Aid flow (current US$) in Korea in 2012?
Keep it short and to the point. 3.38e+08. What is the difference between the Aid flow (current US$) in Denmark in 2005 and the Aid flow (current US$) in Korea in 2012?
Offer a very short reply. 3.40e+08. What is the difference between the Aid flow (current US$) in Austria in 2006 and the Aid flow (current US$) in Belgium in 2007?
Give a very brief answer. -1.09e+08. What is the difference between the Aid flow (current US$) in Austria in 2006 and the Aid flow (current US$) in Denmark in 2007?
Your answer should be very brief. -3.37e+08. What is the difference between the Aid flow (current US$) of Austria in 2006 and the Aid flow (current US$) of Korea in 2007?
Your answer should be compact. 4.70e+08. What is the difference between the Aid flow (current US$) of Belgium in 2006 and the Aid flow (current US$) of Denmark in 2007?
Ensure brevity in your answer.  -4.76e+07. What is the difference between the Aid flow (current US$) in Belgium in 2006 and the Aid flow (current US$) in Korea in 2007?
Make the answer very short. 7.59e+08. What is the difference between the Aid flow (current US$) in Denmark in 2006 and the Aid flow (current US$) in Korea in 2007?
Offer a terse response. 6.75e+08. What is the difference between the Aid flow (current US$) in Austria in 2006 and the Aid flow (current US$) in Belgium in 2008?
Your answer should be compact. -7.12e+07. What is the difference between the Aid flow (current US$) in Austria in 2006 and the Aid flow (current US$) in Denmark in 2008?
Give a very brief answer. -3.40e+08. What is the difference between the Aid flow (current US$) in Austria in 2006 and the Aid flow (current US$) in Korea in 2008?
Offer a terse response. 4.41e+08. What is the difference between the Aid flow (current US$) of Belgium in 2006 and the Aid flow (current US$) of Denmark in 2008?
Your answer should be very brief. -5.09e+07. What is the difference between the Aid flow (current US$) in Belgium in 2006 and the Aid flow (current US$) in Korea in 2008?
Offer a very short reply. 7.30e+08. What is the difference between the Aid flow (current US$) of Denmark in 2006 and the Aid flow (current US$) of Korea in 2008?
Offer a very short reply. 6.45e+08. What is the difference between the Aid flow (current US$) of Austria in 2006 and the Aid flow (current US$) of Belgium in 2009?
Provide a short and direct response. -2.34e+08. What is the difference between the Aid flow (current US$) in Austria in 2006 and the Aid flow (current US$) in Denmark in 2009?
Your response must be concise. -3.37e+08. What is the difference between the Aid flow (current US$) of Austria in 2006 and the Aid flow (current US$) of Korea in 2009?
Your answer should be very brief. 4.47e+08. What is the difference between the Aid flow (current US$) of Belgium in 2006 and the Aid flow (current US$) of Denmark in 2009?
Give a very brief answer. -4.81e+07. What is the difference between the Aid flow (current US$) in Belgium in 2006 and the Aid flow (current US$) in Korea in 2009?
Give a very brief answer. 7.36e+08. What is the difference between the Aid flow (current US$) of Denmark in 2006 and the Aid flow (current US$) of Korea in 2009?
Your answer should be compact. 6.51e+08. What is the difference between the Aid flow (current US$) in Austria in 2006 and the Aid flow (current US$) in Belgium in 2010?
Give a very brief answer. -6.53e+08. What is the difference between the Aid flow (current US$) of Austria in 2006 and the Aid flow (current US$) of Denmark in 2010?
Ensure brevity in your answer.  -3.08e+08. What is the difference between the Aid flow (current US$) of Austria in 2006 and the Aid flow (current US$) of Korea in 2010?
Offer a very short reply. 4.04e+08. What is the difference between the Aid flow (current US$) of Belgium in 2006 and the Aid flow (current US$) of Denmark in 2010?
Ensure brevity in your answer.  -1.87e+07. What is the difference between the Aid flow (current US$) of Belgium in 2006 and the Aid flow (current US$) of Korea in 2010?
Offer a very short reply. 6.93e+08. What is the difference between the Aid flow (current US$) of Denmark in 2006 and the Aid flow (current US$) of Korea in 2010?
Keep it short and to the point. 6.08e+08. What is the difference between the Aid flow (current US$) in Austria in 2006 and the Aid flow (current US$) in Belgium in 2011?
Give a very brief answer. -2.54e+08. What is the difference between the Aid flow (current US$) in Austria in 2006 and the Aid flow (current US$) in Denmark in 2011?
Ensure brevity in your answer.  -4.25e+08. What is the difference between the Aid flow (current US$) of Austria in 2006 and the Aid flow (current US$) of Korea in 2011?
Your answer should be very brief. 3.70e+08. What is the difference between the Aid flow (current US$) in Belgium in 2006 and the Aid flow (current US$) in Denmark in 2011?
Offer a terse response. -1.36e+08. What is the difference between the Aid flow (current US$) in Belgium in 2006 and the Aid flow (current US$) in Korea in 2011?
Offer a terse response. 6.59e+08. What is the difference between the Aid flow (current US$) in Denmark in 2006 and the Aid flow (current US$) in Korea in 2011?
Keep it short and to the point. 5.75e+08. What is the difference between the Aid flow (current US$) in Austria in 2006 and the Aid flow (current US$) in Belgium in 2012?
Keep it short and to the point. -2.27e+08. What is the difference between the Aid flow (current US$) in Austria in 2006 and the Aid flow (current US$) in Denmark in 2012?
Keep it short and to the point. -2.48e+08. What is the difference between the Aid flow (current US$) of Austria in 2006 and the Aid flow (current US$) of Korea in 2012?
Ensure brevity in your answer.  2.86e+08. What is the difference between the Aid flow (current US$) in Belgium in 2006 and the Aid flow (current US$) in Denmark in 2012?
Provide a short and direct response. 4.14e+07. What is the difference between the Aid flow (current US$) in Belgium in 2006 and the Aid flow (current US$) in Korea in 2012?
Your answer should be very brief. 5.76e+08. What is the difference between the Aid flow (current US$) in Denmark in 2006 and the Aid flow (current US$) in Korea in 2012?
Your answer should be compact. 4.91e+08. What is the difference between the Aid flow (current US$) of Austria in 2007 and the Aid flow (current US$) of Belgium in 2008?
Offer a very short reply. -2.09e+08. What is the difference between the Aid flow (current US$) in Austria in 2007 and the Aid flow (current US$) in Denmark in 2008?
Provide a short and direct response. -4.78e+08. What is the difference between the Aid flow (current US$) in Austria in 2007 and the Aid flow (current US$) in Korea in 2008?
Your answer should be very brief. 3.03e+08. What is the difference between the Aid flow (current US$) in Belgium in 2007 and the Aid flow (current US$) in Denmark in 2008?
Your answer should be very brief. -2.31e+08. What is the difference between the Aid flow (current US$) in Belgium in 2007 and the Aid flow (current US$) in Korea in 2008?
Provide a short and direct response. 5.50e+08. What is the difference between the Aid flow (current US$) in Denmark in 2007 and the Aid flow (current US$) in Korea in 2008?
Your response must be concise. 7.78e+08. What is the difference between the Aid flow (current US$) of Austria in 2007 and the Aid flow (current US$) of Belgium in 2009?
Provide a succinct answer. -3.71e+08. What is the difference between the Aid flow (current US$) of Austria in 2007 and the Aid flow (current US$) of Denmark in 2009?
Provide a succinct answer. -4.75e+08. What is the difference between the Aid flow (current US$) of Austria in 2007 and the Aid flow (current US$) of Korea in 2009?
Provide a short and direct response. 3.09e+08. What is the difference between the Aid flow (current US$) of Belgium in 2007 and the Aid flow (current US$) of Denmark in 2009?
Give a very brief answer. -2.28e+08. What is the difference between the Aid flow (current US$) in Belgium in 2007 and the Aid flow (current US$) in Korea in 2009?
Your answer should be compact. 5.56e+08. What is the difference between the Aid flow (current US$) in Denmark in 2007 and the Aid flow (current US$) in Korea in 2009?
Your answer should be very brief. 7.84e+08. What is the difference between the Aid flow (current US$) of Austria in 2007 and the Aid flow (current US$) of Belgium in 2010?
Your response must be concise. -7.91e+08. What is the difference between the Aid flow (current US$) in Austria in 2007 and the Aid flow (current US$) in Denmark in 2010?
Your answer should be compact. -4.46e+08. What is the difference between the Aid flow (current US$) of Austria in 2007 and the Aid flow (current US$) of Korea in 2010?
Ensure brevity in your answer.  2.66e+08. What is the difference between the Aid flow (current US$) of Belgium in 2007 and the Aid flow (current US$) of Denmark in 2010?
Give a very brief answer. -1.99e+08. What is the difference between the Aid flow (current US$) of Belgium in 2007 and the Aid flow (current US$) of Korea in 2010?
Provide a succinct answer. 5.13e+08. What is the difference between the Aid flow (current US$) of Denmark in 2007 and the Aid flow (current US$) of Korea in 2010?
Provide a short and direct response. 7.41e+08. What is the difference between the Aid flow (current US$) in Austria in 2007 and the Aid flow (current US$) in Belgium in 2011?
Give a very brief answer. -3.91e+08. What is the difference between the Aid flow (current US$) in Austria in 2007 and the Aid flow (current US$) in Denmark in 2011?
Offer a very short reply. -5.63e+08. What is the difference between the Aid flow (current US$) of Austria in 2007 and the Aid flow (current US$) of Korea in 2011?
Ensure brevity in your answer.  2.32e+08. What is the difference between the Aid flow (current US$) in Belgium in 2007 and the Aid flow (current US$) in Denmark in 2011?
Make the answer very short. -3.16e+08. What is the difference between the Aid flow (current US$) of Belgium in 2007 and the Aid flow (current US$) of Korea in 2011?
Your answer should be compact. 4.79e+08. What is the difference between the Aid flow (current US$) in Denmark in 2007 and the Aid flow (current US$) in Korea in 2011?
Provide a short and direct response. 7.07e+08. What is the difference between the Aid flow (current US$) in Austria in 2007 and the Aid flow (current US$) in Belgium in 2012?
Provide a short and direct response. -3.65e+08. What is the difference between the Aid flow (current US$) of Austria in 2007 and the Aid flow (current US$) of Denmark in 2012?
Ensure brevity in your answer.  -3.85e+08. What is the difference between the Aid flow (current US$) of Austria in 2007 and the Aid flow (current US$) of Korea in 2012?
Your answer should be compact. 1.49e+08. What is the difference between the Aid flow (current US$) in Belgium in 2007 and the Aid flow (current US$) in Denmark in 2012?
Offer a terse response. -1.39e+08. What is the difference between the Aid flow (current US$) of Belgium in 2007 and the Aid flow (current US$) of Korea in 2012?
Offer a very short reply. 3.96e+08. What is the difference between the Aid flow (current US$) of Denmark in 2007 and the Aid flow (current US$) of Korea in 2012?
Give a very brief answer. 6.23e+08. What is the difference between the Aid flow (current US$) of Austria in 2008 and the Aid flow (current US$) of Belgium in 2009?
Your response must be concise. -6.33e+08. What is the difference between the Aid flow (current US$) in Austria in 2008 and the Aid flow (current US$) in Denmark in 2009?
Offer a very short reply. -7.37e+08. What is the difference between the Aid flow (current US$) in Austria in 2008 and the Aid flow (current US$) in Korea in 2009?
Make the answer very short. 4.74e+07. What is the difference between the Aid flow (current US$) in Belgium in 2008 and the Aid flow (current US$) in Denmark in 2009?
Keep it short and to the point. -2.66e+08. What is the difference between the Aid flow (current US$) in Belgium in 2008 and the Aid flow (current US$) in Korea in 2009?
Your response must be concise. 5.18e+08. What is the difference between the Aid flow (current US$) in Denmark in 2008 and the Aid flow (current US$) in Korea in 2009?
Offer a terse response. 7.87e+08. What is the difference between the Aid flow (current US$) in Austria in 2008 and the Aid flow (current US$) in Belgium in 2010?
Your answer should be very brief. -1.05e+09. What is the difference between the Aid flow (current US$) in Austria in 2008 and the Aid flow (current US$) in Denmark in 2010?
Make the answer very short. -7.08e+08. What is the difference between the Aid flow (current US$) in Austria in 2008 and the Aid flow (current US$) in Korea in 2010?
Make the answer very short. 4.40e+06. What is the difference between the Aid flow (current US$) in Belgium in 2008 and the Aid flow (current US$) in Denmark in 2010?
Your response must be concise. -2.37e+08. What is the difference between the Aid flow (current US$) in Belgium in 2008 and the Aid flow (current US$) in Korea in 2010?
Your answer should be compact. 4.75e+08. What is the difference between the Aid flow (current US$) in Denmark in 2008 and the Aid flow (current US$) in Korea in 2010?
Offer a terse response. 7.44e+08. What is the difference between the Aid flow (current US$) of Austria in 2008 and the Aid flow (current US$) of Belgium in 2011?
Make the answer very short. -6.53e+08. What is the difference between the Aid flow (current US$) in Austria in 2008 and the Aid flow (current US$) in Denmark in 2011?
Your answer should be compact. -8.25e+08. What is the difference between the Aid flow (current US$) in Austria in 2008 and the Aid flow (current US$) in Korea in 2011?
Make the answer very short. -2.95e+07. What is the difference between the Aid flow (current US$) of Belgium in 2008 and the Aid flow (current US$) of Denmark in 2011?
Provide a short and direct response. -3.54e+08. What is the difference between the Aid flow (current US$) in Belgium in 2008 and the Aid flow (current US$) in Korea in 2011?
Give a very brief answer. 4.41e+08. What is the difference between the Aid flow (current US$) in Denmark in 2008 and the Aid flow (current US$) in Korea in 2011?
Provide a succinct answer. 7.10e+08. What is the difference between the Aid flow (current US$) of Austria in 2008 and the Aid flow (current US$) of Belgium in 2012?
Offer a terse response. -6.27e+08. What is the difference between the Aid flow (current US$) in Austria in 2008 and the Aid flow (current US$) in Denmark in 2012?
Keep it short and to the point. -6.47e+08. What is the difference between the Aid flow (current US$) in Austria in 2008 and the Aid flow (current US$) in Korea in 2012?
Make the answer very short. -1.13e+08. What is the difference between the Aid flow (current US$) of Belgium in 2008 and the Aid flow (current US$) of Denmark in 2012?
Your response must be concise. -1.77e+08. What is the difference between the Aid flow (current US$) of Belgium in 2008 and the Aid flow (current US$) of Korea in 2012?
Ensure brevity in your answer.  3.58e+08. What is the difference between the Aid flow (current US$) of Denmark in 2008 and the Aid flow (current US$) of Korea in 2012?
Make the answer very short. 6.27e+08. What is the difference between the Aid flow (current US$) of Austria in 2009 and the Aid flow (current US$) of Belgium in 2010?
Provide a succinct answer. -1.05e+09. What is the difference between the Aid flow (current US$) of Austria in 2009 and the Aid flow (current US$) of Denmark in 2010?
Offer a very short reply. -7.08e+08. What is the difference between the Aid flow (current US$) in Austria in 2009 and the Aid flow (current US$) in Korea in 2010?
Offer a very short reply. 3.49e+06. What is the difference between the Aid flow (current US$) of Belgium in 2009 and the Aid flow (current US$) of Denmark in 2010?
Your response must be concise. -7.45e+07. What is the difference between the Aid flow (current US$) in Belgium in 2009 and the Aid flow (current US$) in Korea in 2010?
Provide a succinct answer. 6.37e+08. What is the difference between the Aid flow (current US$) of Denmark in 2009 and the Aid flow (current US$) of Korea in 2010?
Offer a very short reply. 7.41e+08. What is the difference between the Aid flow (current US$) in Austria in 2009 and the Aid flow (current US$) in Belgium in 2011?
Provide a short and direct response. -6.54e+08. What is the difference between the Aid flow (current US$) in Austria in 2009 and the Aid flow (current US$) in Denmark in 2011?
Ensure brevity in your answer.  -8.26e+08. What is the difference between the Aid flow (current US$) in Austria in 2009 and the Aid flow (current US$) in Korea in 2011?
Provide a succinct answer. -3.04e+07. What is the difference between the Aid flow (current US$) of Belgium in 2009 and the Aid flow (current US$) of Denmark in 2011?
Provide a succinct answer. -1.92e+08. What is the difference between the Aid flow (current US$) of Belgium in 2009 and the Aid flow (current US$) of Korea in 2011?
Make the answer very short. 6.04e+08. What is the difference between the Aid flow (current US$) of Denmark in 2009 and the Aid flow (current US$) of Korea in 2011?
Your response must be concise. 7.07e+08. What is the difference between the Aid flow (current US$) in Austria in 2009 and the Aid flow (current US$) in Belgium in 2012?
Your answer should be compact. -6.28e+08. What is the difference between the Aid flow (current US$) in Austria in 2009 and the Aid flow (current US$) in Denmark in 2012?
Provide a short and direct response. -6.48e+08. What is the difference between the Aid flow (current US$) of Austria in 2009 and the Aid flow (current US$) of Korea in 2012?
Keep it short and to the point. -1.14e+08. What is the difference between the Aid flow (current US$) of Belgium in 2009 and the Aid flow (current US$) of Denmark in 2012?
Make the answer very short. -1.43e+07. What is the difference between the Aid flow (current US$) in Belgium in 2009 and the Aid flow (current US$) in Korea in 2012?
Give a very brief answer. 5.20e+08. What is the difference between the Aid flow (current US$) of Denmark in 2009 and the Aid flow (current US$) of Korea in 2012?
Your answer should be very brief. 6.24e+08. What is the difference between the Aid flow (current US$) of Austria in 2010 and the Aid flow (current US$) of Belgium in 2011?
Provide a succinct answer. -5.55e+08. What is the difference between the Aid flow (current US$) of Austria in 2010 and the Aid flow (current US$) of Denmark in 2011?
Ensure brevity in your answer.  -7.27e+08. What is the difference between the Aid flow (current US$) of Austria in 2010 and the Aid flow (current US$) of Korea in 2011?
Make the answer very short. 6.84e+07. What is the difference between the Aid flow (current US$) in Belgium in 2010 and the Aid flow (current US$) in Denmark in 2011?
Keep it short and to the point. 2.28e+08. What is the difference between the Aid flow (current US$) of Belgium in 2010 and the Aid flow (current US$) of Korea in 2011?
Offer a very short reply. 1.02e+09. What is the difference between the Aid flow (current US$) in Denmark in 2010 and the Aid flow (current US$) in Korea in 2011?
Give a very brief answer. 6.78e+08. What is the difference between the Aid flow (current US$) in Austria in 2010 and the Aid flow (current US$) in Belgium in 2012?
Your answer should be very brief. -5.29e+08. What is the difference between the Aid flow (current US$) in Austria in 2010 and the Aid flow (current US$) in Denmark in 2012?
Offer a very short reply. -5.50e+08. What is the difference between the Aid flow (current US$) in Austria in 2010 and the Aid flow (current US$) in Korea in 2012?
Give a very brief answer. -1.53e+07. What is the difference between the Aid flow (current US$) in Belgium in 2010 and the Aid flow (current US$) in Denmark in 2012?
Ensure brevity in your answer.  4.06e+08. What is the difference between the Aid flow (current US$) in Belgium in 2010 and the Aid flow (current US$) in Korea in 2012?
Ensure brevity in your answer.  9.40e+08. What is the difference between the Aid flow (current US$) of Denmark in 2010 and the Aid flow (current US$) of Korea in 2012?
Give a very brief answer. 5.94e+08. What is the difference between the Aid flow (current US$) of Austria in 2011 and the Aid flow (current US$) of Belgium in 2012?
Your answer should be compact. -6.43e+08. What is the difference between the Aid flow (current US$) of Austria in 2011 and the Aid flow (current US$) of Denmark in 2012?
Keep it short and to the point. -6.63e+08. What is the difference between the Aid flow (current US$) of Austria in 2011 and the Aid flow (current US$) of Korea in 2012?
Your answer should be very brief. -1.29e+08. What is the difference between the Aid flow (current US$) in Belgium in 2011 and the Aid flow (current US$) in Denmark in 2012?
Make the answer very short. 5.92e+06. What is the difference between the Aid flow (current US$) in Belgium in 2011 and the Aid flow (current US$) in Korea in 2012?
Make the answer very short. 5.40e+08. What is the difference between the Aid flow (current US$) of Denmark in 2011 and the Aid flow (current US$) of Korea in 2012?
Your answer should be compact. 7.12e+08. What is the average Aid flow (current US$) in Austria per year?
Provide a short and direct response. 2.15e+08. What is the average Aid flow (current US$) of Belgium per year?
Provide a succinct answer. 7.38e+08. What is the average Aid flow (current US$) of Denmark per year?
Offer a very short reply. 7.77e+08. What is the average Aid flow (current US$) in Korea per year?
Provide a succinct answer. 9.39e+07. In the year 2004, what is the difference between the Aid flow (current US$) of Austria and Aid flow (current US$) of Belgium?
Your answer should be very brief. -3.97e+08. In the year 2004, what is the difference between the Aid flow (current US$) in Austria and Aid flow (current US$) in Denmark?
Your answer should be very brief. -3.83e+08. In the year 2004, what is the difference between the Aid flow (current US$) in Austria and Aid flow (current US$) in Korea?
Provide a short and direct response. 1.03e+08. In the year 2004, what is the difference between the Aid flow (current US$) of Belgium and Aid flow (current US$) of Denmark?
Provide a short and direct response. 1.43e+07. In the year 2004, what is the difference between the Aid flow (current US$) in Belgium and Aid flow (current US$) in Korea?
Keep it short and to the point. 5.01e+08. In the year 2004, what is the difference between the Aid flow (current US$) in Denmark and Aid flow (current US$) in Korea?
Give a very brief answer. 4.86e+08. In the year 2005, what is the difference between the Aid flow (current US$) in Austria and Aid flow (current US$) in Belgium?
Give a very brief answer. -4.53e+08. In the year 2005, what is the difference between the Aid flow (current US$) of Austria and Aid flow (current US$) of Denmark?
Make the answer very short. -4.55e+08. In the year 2005, what is the difference between the Aid flow (current US$) in Austria and Aid flow (current US$) in Korea?
Keep it short and to the point. 9.33e+07. In the year 2005, what is the difference between the Aid flow (current US$) in Belgium and Aid flow (current US$) in Denmark?
Your answer should be compact. -2.30e+06. In the year 2005, what is the difference between the Aid flow (current US$) in Belgium and Aid flow (current US$) in Korea?
Provide a short and direct response. 5.46e+08. In the year 2005, what is the difference between the Aid flow (current US$) of Denmark and Aid flow (current US$) of Korea?
Your answer should be very brief. 5.48e+08. In the year 2006, what is the difference between the Aid flow (current US$) in Austria and Aid flow (current US$) in Belgium?
Your answer should be very brief. -2.89e+08. In the year 2006, what is the difference between the Aid flow (current US$) in Austria and Aid flow (current US$) in Denmark?
Provide a short and direct response. -2.04e+08. In the year 2006, what is the difference between the Aid flow (current US$) of Austria and Aid flow (current US$) of Korea?
Offer a very short reply. 4.90e+08. In the year 2006, what is the difference between the Aid flow (current US$) in Belgium and Aid flow (current US$) in Denmark?
Make the answer very short. 8.48e+07. In the year 2006, what is the difference between the Aid flow (current US$) in Belgium and Aid flow (current US$) in Korea?
Provide a succinct answer. 7.79e+08. In the year 2006, what is the difference between the Aid flow (current US$) of Denmark and Aid flow (current US$) of Korea?
Offer a terse response. 6.94e+08. In the year 2007, what is the difference between the Aid flow (current US$) in Austria and Aid flow (current US$) in Belgium?
Your answer should be compact. -2.47e+08. In the year 2007, what is the difference between the Aid flow (current US$) of Austria and Aid flow (current US$) of Denmark?
Offer a very short reply. -4.75e+08. In the year 2007, what is the difference between the Aid flow (current US$) of Austria and Aid flow (current US$) of Korea?
Provide a short and direct response. 3.33e+08. In the year 2007, what is the difference between the Aid flow (current US$) of Belgium and Aid flow (current US$) of Denmark?
Your answer should be compact. -2.28e+08. In the year 2007, what is the difference between the Aid flow (current US$) of Belgium and Aid flow (current US$) of Korea?
Keep it short and to the point. 5.79e+08. In the year 2007, what is the difference between the Aid flow (current US$) in Denmark and Aid flow (current US$) in Korea?
Offer a very short reply. 8.07e+08. In the year 2008, what is the difference between the Aid flow (current US$) in Austria and Aid flow (current US$) in Belgium?
Keep it short and to the point. -4.71e+08. In the year 2008, what is the difference between the Aid flow (current US$) in Austria and Aid flow (current US$) in Denmark?
Ensure brevity in your answer.  -7.40e+08. In the year 2008, what is the difference between the Aid flow (current US$) of Austria and Aid flow (current US$) of Korea?
Your response must be concise. 4.12e+07. In the year 2008, what is the difference between the Aid flow (current US$) of Belgium and Aid flow (current US$) of Denmark?
Your response must be concise. -2.69e+08. In the year 2008, what is the difference between the Aid flow (current US$) of Belgium and Aid flow (current US$) of Korea?
Offer a very short reply. 5.12e+08. In the year 2008, what is the difference between the Aid flow (current US$) of Denmark and Aid flow (current US$) of Korea?
Your response must be concise. 7.81e+08. In the year 2009, what is the difference between the Aid flow (current US$) of Austria and Aid flow (current US$) of Belgium?
Offer a terse response. -6.34e+08. In the year 2009, what is the difference between the Aid flow (current US$) of Austria and Aid flow (current US$) of Denmark?
Your answer should be very brief. -7.38e+08. In the year 2009, what is the difference between the Aid flow (current US$) in Austria and Aid flow (current US$) in Korea?
Keep it short and to the point. 4.64e+07. In the year 2009, what is the difference between the Aid flow (current US$) in Belgium and Aid flow (current US$) in Denmark?
Give a very brief answer. -1.04e+08. In the year 2009, what is the difference between the Aid flow (current US$) of Belgium and Aid flow (current US$) of Korea?
Offer a very short reply. 6.80e+08. In the year 2009, what is the difference between the Aid flow (current US$) of Denmark and Aid flow (current US$) of Korea?
Provide a short and direct response. 7.84e+08. In the year 2010, what is the difference between the Aid flow (current US$) in Austria and Aid flow (current US$) in Belgium?
Keep it short and to the point. -9.55e+08. In the year 2010, what is the difference between the Aid flow (current US$) of Austria and Aid flow (current US$) of Denmark?
Your answer should be compact. -6.10e+08. In the year 2010, what is the difference between the Aid flow (current US$) of Austria and Aid flow (current US$) of Korea?
Make the answer very short. 1.02e+08. In the year 2010, what is the difference between the Aid flow (current US$) in Belgium and Aid flow (current US$) in Denmark?
Offer a very short reply. 3.45e+08. In the year 2010, what is the difference between the Aid flow (current US$) in Belgium and Aid flow (current US$) in Korea?
Provide a short and direct response. 1.06e+09. In the year 2010, what is the difference between the Aid flow (current US$) in Denmark and Aid flow (current US$) in Korea?
Provide a short and direct response. 7.12e+08. In the year 2011, what is the difference between the Aid flow (current US$) of Austria and Aid flow (current US$) of Belgium?
Make the answer very short. -6.69e+08. In the year 2011, what is the difference between the Aid flow (current US$) in Austria and Aid flow (current US$) in Denmark?
Offer a very short reply. -8.41e+08. In the year 2011, what is the difference between the Aid flow (current US$) in Austria and Aid flow (current US$) in Korea?
Keep it short and to the point. -4.53e+07. In the year 2011, what is the difference between the Aid flow (current US$) in Belgium and Aid flow (current US$) in Denmark?
Make the answer very short. -1.72e+08. In the year 2011, what is the difference between the Aid flow (current US$) of Belgium and Aid flow (current US$) of Korea?
Give a very brief answer. 6.24e+08. In the year 2011, what is the difference between the Aid flow (current US$) in Denmark and Aid flow (current US$) in Korea?
Offer a very short reply. 7.95e+08. In the year 2012, what is the difference between the Aid flow (current US$) of Austria and Aid flow (current US$) of Belgium?
Make the answer very short. -5.91e+08. In the year 2012, what is the difference between the Aid flow (current US$) in Austria and Aid flow (current US$) in Denmark?
Make the answer very short. -6.12e+08. In the year 2012, what is the difference between the Aid flow (current US$) in Austria and Aid flow (current US$) in Korea?
Provide a short and direct response. -7.79e+07. In the year 2012, what is the difference between the Aid flow (current US$) of Belgium and Aid flow (current US$) of Denmark?
Provide a short and direct response. -2.07e+07. In the year 2012, what is the difference between the Aid flow (current US$) of Belgium and Aid flow (current US$) of Korea?
Offer a terse response. 5.14e+08. In the year 2012, what is the difference between the Aid flow (current US$) in Denmark and Aid flow (current US$) in Korea?
Your answer should be very brief. 5.34e+08. What is the ratio of the Aid flow (current US$) in Austria in 2004 to that in 2005?
Offer a terse response. 0.99. What is the ratio of the Aid flow (current US$) in Belgium in 2004 to that in 2005?
Offer a very short reply. 0.9. What is the ratio of the Aid flow (current US$) in Denmark in 2004 to that in 2005?
Provide a short and direct response. 0.87. What is the ratio of the Aid flow (current US$) of Korea in 2004 to that in 2005?
Your response must be concise. 0.66. What is the ratio of the Aid flow (current US$) of Austria in 2004 to that in 2006?
Provide a succinct answer. 0.24. What is the ratio of the Aid flow (current US$) of Belgium in 2004 to that in 2006?
Your response must be concise. 0.64. What is the ratio of the Aid flow (current US$) of Denmark in 2004 to that in 2006?
Give a very brief answer. 0.69. What is the ratio of the Aid flow (current US$) of Korea in 2004 to that in 2006?
Provide a short and direct response. 0.57. What is the ratio of the Aid flow (current US$) in Austria in 2004 to that in 2007?
Provide a succinct answer. 0.32. What is the ratio of the Aid flow (current US$) in Belgium in 2004 to that in 2007?
Your answer should be very brief. 0.82. What is the ratio of the Aid flow (current US$) of Denmark in 2004 to that in 2007?
Offer a terse response. 0.59. What is the ratio of the Aid flow (current US$) in Korea in 2004 to that in 2007?
Your response must be concise. 0.38. What is the ratio of the Aid flow (current US$) in Austria in 2004 to that in 2008?
Offer a terse response. 0.97. What is the ratio of the Aid flow (current US$) of Belgium in 2004 to that in 2008?
Offer a very short reply. 0.87. What is the ratio of the Aid flow (current US$) in Denmark in 2004 to that in 2008?
Offer a very short reply. 0.59. What is the ratio of the Aid flow (current US$) in Korea in 2004 to that in 2008?
Provide a succinct answer. 0.25. What is the ratio of the Aid flow (current US$) of Austria in 2004 to that in 2009?
Offer a terse response. 0.98. What is the ratio of the Aid flow (current US$) of Belgium in 2004 to that in 2009?
Keep it short and to the point. 0.69. What is the ratio of the Aid flow (current US$) of Denmark in 2004 to that in 2009?
Offer a very short reply. 0.59. What is the ratio of the Aid flow (current US$) in Korea in 2004 to that in 2009?
Make the answer very short. 0.27. What is the ratio of the Aid flow (current US$) of Austria in 2004 to that in 2010?
Keep it short and to the point. 0.55. What is the ratio of the Aid flow (current US$) of Belgium in 2004 to that in 2010?
Ensure brevity in your answer.  0.44. What is the ratio of the Aid flow (current US$) in Denmark in 2004 to that in 2010?
Offer a terse response. 0.61. What is the ratio of the Aid flow (current US$) in Korea in 2004 to that in 2010?
Provide a short and direct response. 0.18. What is the ratio of the Aid flow (current US$) of Austria in 2004 to that in 2011?
Ensure brevity in your answer.  1.11. What is the ratio of the Aid flow (current US$) of Belgium in 2004 to that in 2011?
Provide a short and direct response. 0.67. What is the ratio of the Aid flow (current US$) of Denmark in 2004 to that in 2011?
Provide a succinct answer. 0.53. What is the ratio of the Aid flow (current US$) in Korea in 2004 to that in 2011?
Keep it short and to the point. 0.14. What is the ratio of the Aid flow (current US$) in Austria in 2004 to that in 2012?
Keep it short and to the point. 0.76. What is the ratio of the Aid flow (current US$) of Belgium in 2004 to that in 2012?
Your answer should be very brief. 0.69. What is the ratio of the Aid flow (current US$) in Denmark in 2004 to that in 2012?
Offer a terse response. 0.65. What is the ratio of the Aid flow (current US$) in Korea in 2004 to that in 2012?
Make the answer very short. 0.09. What is the ratio of the Aid flow (current US$) of Austria in 2005 to that in 2006?
Offer a very short reply. 0.24. What is the ratio of the Aid flow (current US$) in Belgium in 2005 to that in 2006?
Keep it short and to the point. 0.71. What is the ratio of the Aid flow (current US$) in Denmark in 2005 to that in 2006?
Your response must be concise. 0.79. What is the ratio of the Aid flow (current US$) in Korea in 2005 to that in 2006?
Provide a succinct answer. 0.87. What is the ratio of the Aid flow (current US$) in Austria in 2005 to that in 2007?
Your answer should be compact. 0.32. What is the ratio of the Aid flow (current US$) in Belgium in 2005 to that in 2007?
Offer a terse response. 0.91. What is the ratio of the Aid flow (current US$) of Denmark in 2005 to that in 2007?
Ensure brevity in your answer.  0.67. What is the ratio of the Aid flow (current US$) in Korea in 2005 to that in 2007?
Make the answer very short. 0.57. What is the ratio of the Aid flow (current US$) in Austria in 2005 to that in 2008?
Your response must be concise. 0.98. What is the ratio of the Aid flow (current US$) of Belgium in 2005 to that in 2008?
Keep it short and to the point. 0.97. What is the ratio of the Aid flow (current US$) of Denmark in 2005 to that in 2008?
Your response must be concise. 0.67. What is the ratio of the Aid flow (current US$) in Korea in 2005 to that in 2008?
Make the answer very short. 0.38. What is the ratio of the Aid flow (current US$) in Austria in 2005 to that in 2009?
Offer a terse response. 0.99. What is the ratio of the Aid flow (current US$) of Belgium in 2005 to that in 2009?
Offer a very short reply. 0.76. What is the ratio of the Aid flow (current US$) of Denmark in 2005 to that in 2009?
Offer a terse response. 0.67. What is the ratio of the Aid flow (current US$) in Korea in 2005 to that in 2009?
Your response must be concise. 0.41. What is the ratio of the Aid flow (current US$) of Austria in 2005 to that in 2010?
Ensure brevity in your answer.  0.56. What is the ratio of the Aid flow (current US$) of Belgium in 2005 to that in 2010?
Offer a terse response. 0.49. What is the ratio of the Aid flow (current US$) of Denmark in 2005 to that in 2010?
Your response must be concise. 0.7. What is the ratio of the Aid flow (current US$) of Korea in 2005 to that in 2010?
Offer a very short reply. 0.27. What is the ratio of the Aid flow (current US$) in Austria in 2005 to that in 2011?
Ensure brevity in your answer.  1.12. What is the ratio of the Aid flow (current US$) of Belgium in 2005 to that in 2011?
Offer a very short reply. 0.74. What is the ratio of the Aid flow (current US$) in Denmark in 2005 to that in 2011?
Provide a succinct answer. 0.61. What is the ratio of the Aid flow (current US$) of Korea in 2005 to that in 2011?
Offer a terse response. 0.21. What is the ratio of the Aid flow (current US$) of Austria in 2005 to that in 2012?
Offer a very short reply. 0.77. What is the ratio of the Aid flow (current US$) of Belgium in 2005 to that in 2012?
Provide a succinct answer. 0.77. What is the ratio of the Aid flow (current US$) of Denmark in 2005 to that in 2012?
Offer a terse response. 0.75. What is the ratio of the Aid flow (current US$) in Korea in 2005 to that in 2012?
Your response must be concise. 0.14. What is the ratio of the Aid flow (current US$) of Austria in 2006 to that in 2007?
Provide a short and direct response. 1.35. What is the ratio of the Aid flow (current US$) of Belgium in 2006 to that in 2007?
Offer a terse response. 1.28. What is the ratio of the Aid flow (current US$) of Denmark in 2006 to that in 2007?
Keep it short and to the point. 0.85. What is the ratio of the Aid flow (current US$) in Korea in 2006 to that in 2007?
Provide a succinct answer. 0.66. What is the ratio of the Aid flow (current US$) of Austria in 2006 to that in 2008?
Provide a succinct answer. 4.1. What is the ratio of the Aid flow (current US$) in Belgium in 2006 to that in 2008?
Your answer should be compact. 1.36. What is the ratio of the Aid flow (current US$) in Denmark in 2006 to that in 2008?
Provide a short and direct response. 0.84. What is the ratio of the Aid flow (current US$) of Korea in 2006 to that in 2008?
Give a very brief answer. 0.44. What is the ratio of the Aid flow (current US$) of Austria in 2006 to that in 2009?
Keep it short and to the point. 4.13. What is the ratio of the Aid flow (current US$) of Belgium in 2006 to that in 2009?
Ensure brevity in your answer.  1.07. What is the ratio of the Aid flow (current US$) in Denmark in 2006 to that in 2009?
Offer a very short reply. 0.85. What is the ratio of the Aid flow (current US$) in Korea in 2006 to that in 2009?
Provide a succinct answer. 0.47. What is the ratio of the Aid flow (current US$) in Austria in 2006 to that in 2010?
Give a very brief answer. 2.33. What is the ratio of the Aid flow (current US$) in Belgium in 2006 to that in 2010?
Make the answer very short. 0.69. What is the ratio of the Aid flow (current US$) of Denmark in 2006 to that in 2010?
Ensure brevity in your answer.  0.88. What is the ratio of the Aid flow (current US$) in Korea in 2006 to that in 2010?
Give a very brief answer. 0.31. What is the ratio of the Aid flow (current US$) in Austria in 2006 to that in 2011?
Your response must be concise. 4.68. What is the ratio of the Aid flow (current US$) in Belgium in 2006 to that in 2011?
Provide a short and direct response. 1.05. What is the ratio of the Aid flow (current US$) of Denmark in 2006 to that in 2011?
Offer a very short reply. 0.77. What is the ratio of the Aid flow (current US$) in Korea in 2006 to that in 2011?
Offer a very short reply. 0.24. What is the ratio of the Aid flow (current US$) in Austria in 2006 to that in 2012?
Your response must be concise. 3.22. What is the ratio of the Aid flow (current US$) in Belgium in 2006 to that in 2012?
Your answer should be very brief. 1.08. What is the ratio of the Aid flow (current US$) in Denmark in 2006 to that in 2012?
Make the answer very short. 0.94. What is the ratio of the Aid flow (current US$) of Korea in 2006 to that in 2012?
Provide a short and direct response. 0.16. What is the ratio of the Aid flow (current US$) of Austria in 2007 to that in 2008?
Provide a short and direct response. 3.03. What is the ratio of the Aid flow (current US$) of Belgium in 2007 to that in 2008?
Offer a very short reply. 1.06. What is the ratio of the Aid flow (current US$) in Korea in 2007 to that in 2008?
Give a very brief answer. 0.66. What is the ratio of the Aid flow (current US$) in Austria in 2007 to that in 2009?
Ensure brevity in your answer.  3.06. What is the ratio of the Aid flow (current US$) of Belgium in 2007 to that in 2009?
Your answer should be very brief. 0.84. What is the ratio of the Aid flow (current US$) in Denmark in 2007 to that in 2009?
Ensure brevity in your answer.  1. What is the ratio of the Aid flow (current US$) of Korea in 2007 to that in 2009?
Give a very brief answer. 0.71. What is the ratio of the Aid flow (current US$) of Austria in 2007 to that in 2010?
Your response must be concise. 1.72. What is the ratio of the Aid flow (current US$) in Belgium in 2007 to that in 2010?
Offer a terse response. 0.54. What is the ratio of the Aid flow (current US$) of Denmark in 2007 to that in 2010?
Make the answer very short. 1.03. What is the ratio of the Aid flow (current US$) of Korea in 2007 to that in 2010?
Your answer should be compact. 0.47. What is the ratio of the Aid flow (current US$) of Austria in 2007 to that in 2011?
Offer a very short reply. 3.46. What is the ratio of the Aid flow (current US$) in Belgium in 2007 to that in 2011?
Your answer should be very brief. 0.82. What is the ratio of the Aid flow (current US$) in Denmark in 2007 to that in 2011?
Provide a succinct answer. 0.91. What is the ratio of the Aid flow (current US$) in Korea in 2007 to that in 2011?
Keep it short and to the point. 0.37. What is the ratio of the Aid flow (current US$) of Austria in 2007 to that in 2012?
Your response must be concise. 2.38. What is the ratio of the Aid flow (current US$) in Belgium in 2007 to that in 2012?
Ensure brevity in your answer.  0.84. What is the ratio of the Aid flow (current US$) in Denmark in 2007 to that in 2012?
Provide a short and direct response. 1.11. What is the ratio of the Aid flow (current US$) of Korea in 2007 to that in 2012?
Provide a succinct answer. 0.24. What is the ratio of the Aid flow (current US$) of Austria in 2008 to that in 2009?
Your answer should be compact. 1.01. What is the ratio of the Aid flow (current US$) in Belgium in 2008 to that in 2009?
Make the answer very short. 0.79. What is the ratio of the Aid flow (current US$) of Korea in 2008 to that in 2009?
Provide a succinct answer. 1.08. What is the ratio of the Aid flow (current US$) of Austria in 2008 to that in 2010?
Make the answer very short. 0.57. What is the ratio of the Aid flow (current US$) in Belgium in 2008 to that in 2010?
Ensure brevity in your answer.  0.51. What is the ratio of the Aid flow (current US$) in Denmark in 2008 to that in 2010?
Provide a succinct answer. 1.04. What is the ratio of the Aid flow (current US$) of Korea in 2008 to that in 2010?
Your answer should be compact. 0.7. What is the ratio of the Aid flow (current US$) of Austria in 2008 to that in 2011?
Keep it short and to the point. 1.14. What is the ratio of the Aid flow (current US$) of Belgium in 2008 to that in 2011?
Ensure brevity in your answer.  0.77. What is the ratio of the Aid flow (current US$) of Denmark in 2008 to that in 2011?
Give a very brief answer. 0.91. What is the ratio of the Aid flow (current US$) of Korea in 2008 to that in 2011?
Make the answer very short. 0.55. What is the ratio of the Aid flow (current US$) in Austria in 2008 to that in 2012?
Offer a very short reply. 0.79. What is the ratio of the Aid flow (current US$) in Belgium in 2008 to that in 2012?
Your answer should be compact. 0.79. What is the ratio of the Aid flow (current US$) of Denmark in 2008 to that in 2012?
Make the answer very short. 1.12. What is the ratio of the Aid flow (current US$) in Korea in 2008 to that in 2012?
Keep it short and to the point. 0.36. What is the ratio of the Aid flow (current US$) in Austria in 2009 to that in 2010?
Provide a short and direct response. 0.56. What is the ratio of the Aid flow (current US$) in Belgium in 2009 to that in 2010?
Provide a succinct answer. 0.64. What is the ratio of the Aid flow (current US$) of Denmark in 2009 to that in 2010?
Your answer should be very brief. 1.04. What is the ratio of the Aid flow (current US$) of Korea in 2009 to that in 2010?
Your answer should be very brief. 0.65. What is the ratio of the Aid flow (current US$) of Austria in 2009 to that in 2011?
Provide a short and direct response. 1.13. What is the ratio of the Aid flow (current US$) of Belgium in 2009 to that in 2011?
Ensure brevity in your answer.  0.97. What is the ratio of the Aid flow (current US$) in Denmark in 2009 to that in 2011?
Keep it short and to the point. 0.91. What is the ratio of the Aid flow (current US$) of Korea in 2009 to that in 2011?
Provide a succinct answer. 0.51. What is the ratio of the Aid flow (current US$) of Austria in 2009 to that in 2012?
Your answer should be very brief. 0.78. What is the ratio of the Aid flow (current US$) of Belgium in 2009 to that in 2012?
Make the answer very short. 1.01. What is the ratio of the Aid flow (current US$) of Denmark in 2009 to that in 2012?
Provide a short and direct response. 1.12. What is the ratio of the Aid flow (current US$) of Korea in 2009 to that in 2012?
Make the answer very short. 0.34. What is the ratio of the Aid flow (current US$) of Austria in 2010 to that in 2011?
Give a very brief answer. 2.01. What is the ratio of the Aid flow (current US$) in Belgium in 2010 to that in 2011?
Your answer should be compact. 1.51. What is the ratio of the Aid flow (current US$) in Denmark in 2010 to that in 2011?
Provide a succinct answer. 0.88. What is the ratio of the Aid flow (current US$) of Korea in 2010 to that in 2011?
Your answer should be compact. 0.79. What is the ratio of the Aid flow (current US$) of Austria in 2010 to that in 2012?
Your answer should be compact. 1.38. What is the ratio of the Aid flow (current US$) of Belgium in 2010 to that in 2012?
Your response must be concise. 1.56. What is the ratio of the Aid flow (current US$) of Denmark in 2010 to that in 2012?
Keep it short and to the point. 1.08. What is the ratio of the Aid flow (current US$) in Korea in 2010 to that in 2012?
Your response must be concise. 0.51. What is the ratio of the Aid flow (current US$) in Austria in 2011 to that in 2012?
Your answer should be compact. 0.69. What is the ratio of the Aid flow (current US$) of Belgium in 2011 to that in 2012?
Make the answer very short. 1.04. What is the ratio of the Aid flow (current US$) of Denmark in 2011 to that in 2012?
Provide a succinct answer. 1.23. What is the ratio of the Aid flow (current US$) in Korea in 2011 to that in 2012?
Ensure brevity in your answer.  0.65. What is the difference between the highest and the second highest Aid flow (current US$) of Austria?
Keep it short and to the point. 1.38e+08. What is the difference between the highest and the second highest Aid flow (current US$) of Belgium?
Offer a very short reply. 3.64e+08. What is the difference between the highest and the second highest Aid flow (current US$) in Denmark?
Give a very brief answer. 8.52e+07. What is the difference between the highest and the second highest Aid flow (current US$) of Korea?
Your response must be concise. 8.37e+07. What is the difference between the highest and the lowest Aid flow (current US$) in Austria?
Your answer should be compact. 4.15e+08. What is the difference between the highest and the lowest Aid flow (current US$) in Belgium?
Keep it short and to the point. 6.59e+08. What is the difference between the highest and the lowest Aid flow (current US$) in Denmark?
Make the answer very short. 4.45e+08. What is the difference between the highest and the lowest Aid flow (current US$) in Korea?
Your response must be concise. 2.20e+08. 